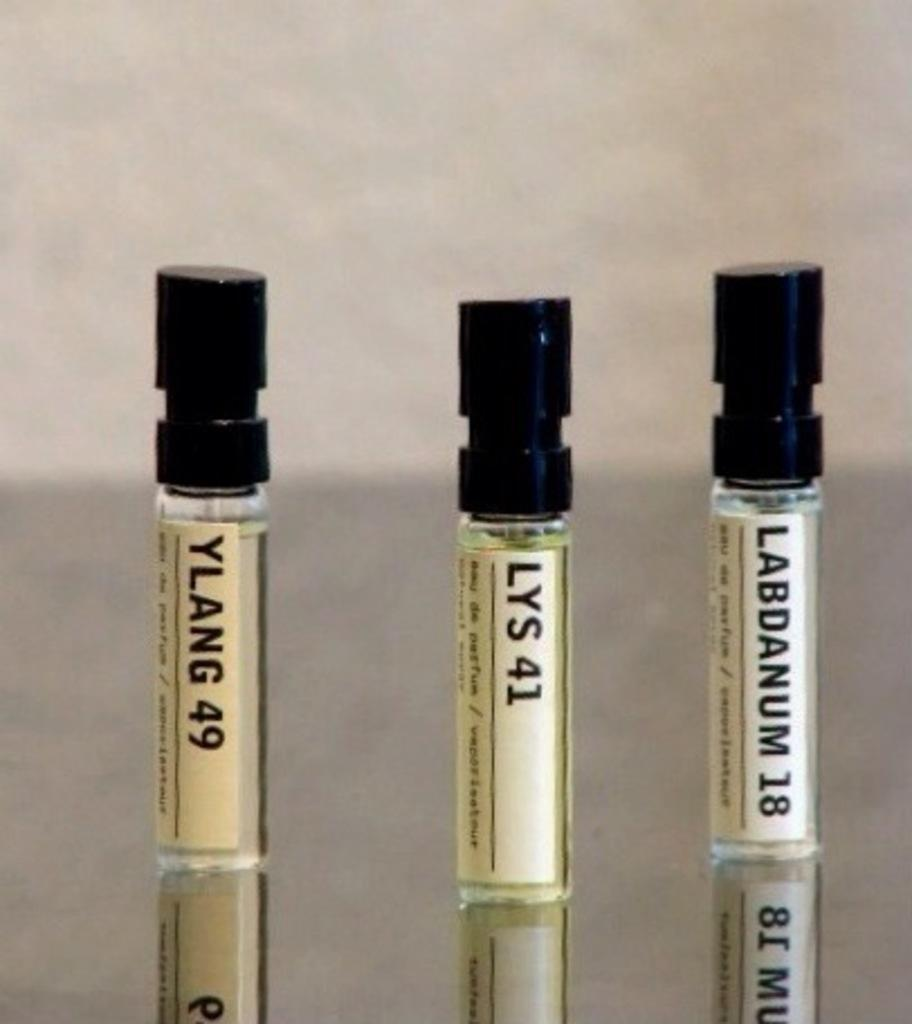What is the main subject of the image? The main subject of the subject of the image is three samples of perfume. How are the perfume samples presented in the image? The perfume samples are in small bottles. What type of mailbox can be seen near the perfume samples in the image? There is no mailbox present in the image; it only features three samples of perfume in small bottles. 